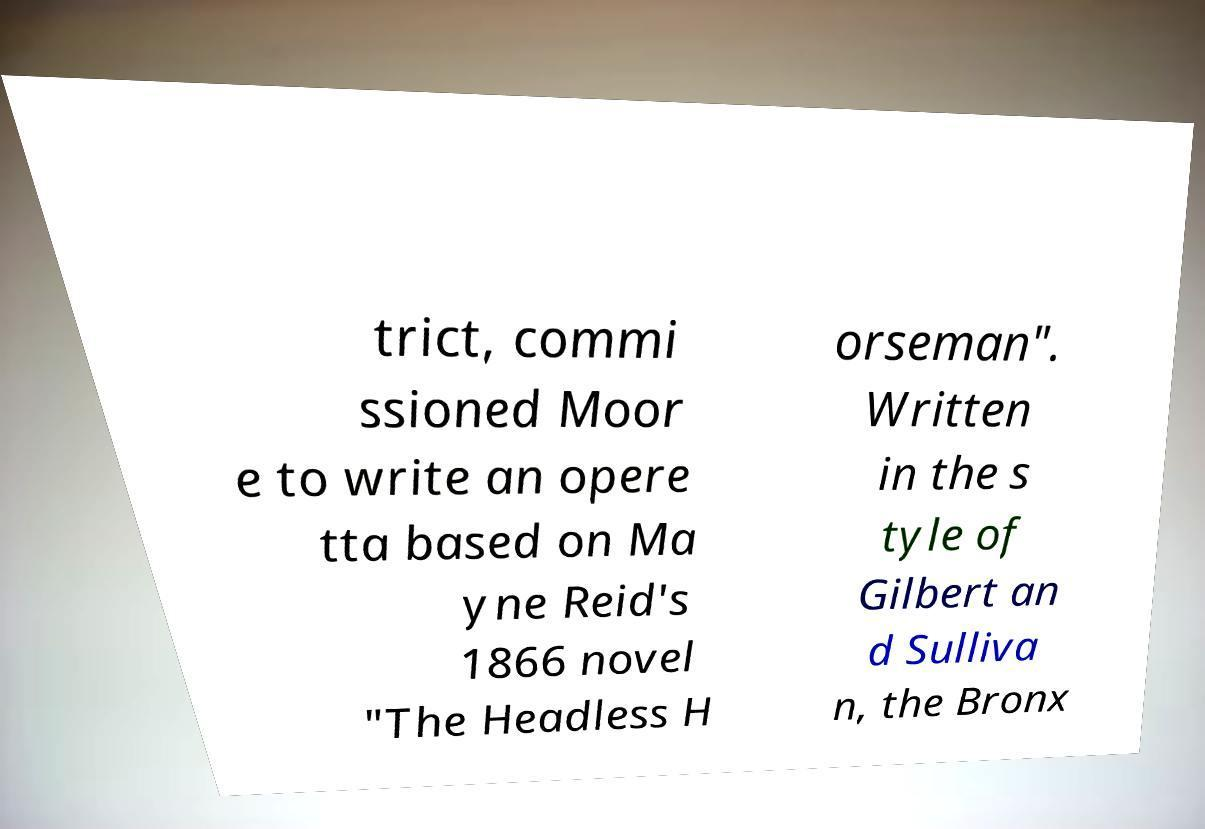Please identify and transcribe the text found in this image. trict, commi ssioned Moor e to write an opere tta based on Ma yne Reid's 1866 novel "The Headless H orseman". Written in the s tyle of Gilbert an d Sulliva n, the Bronx 